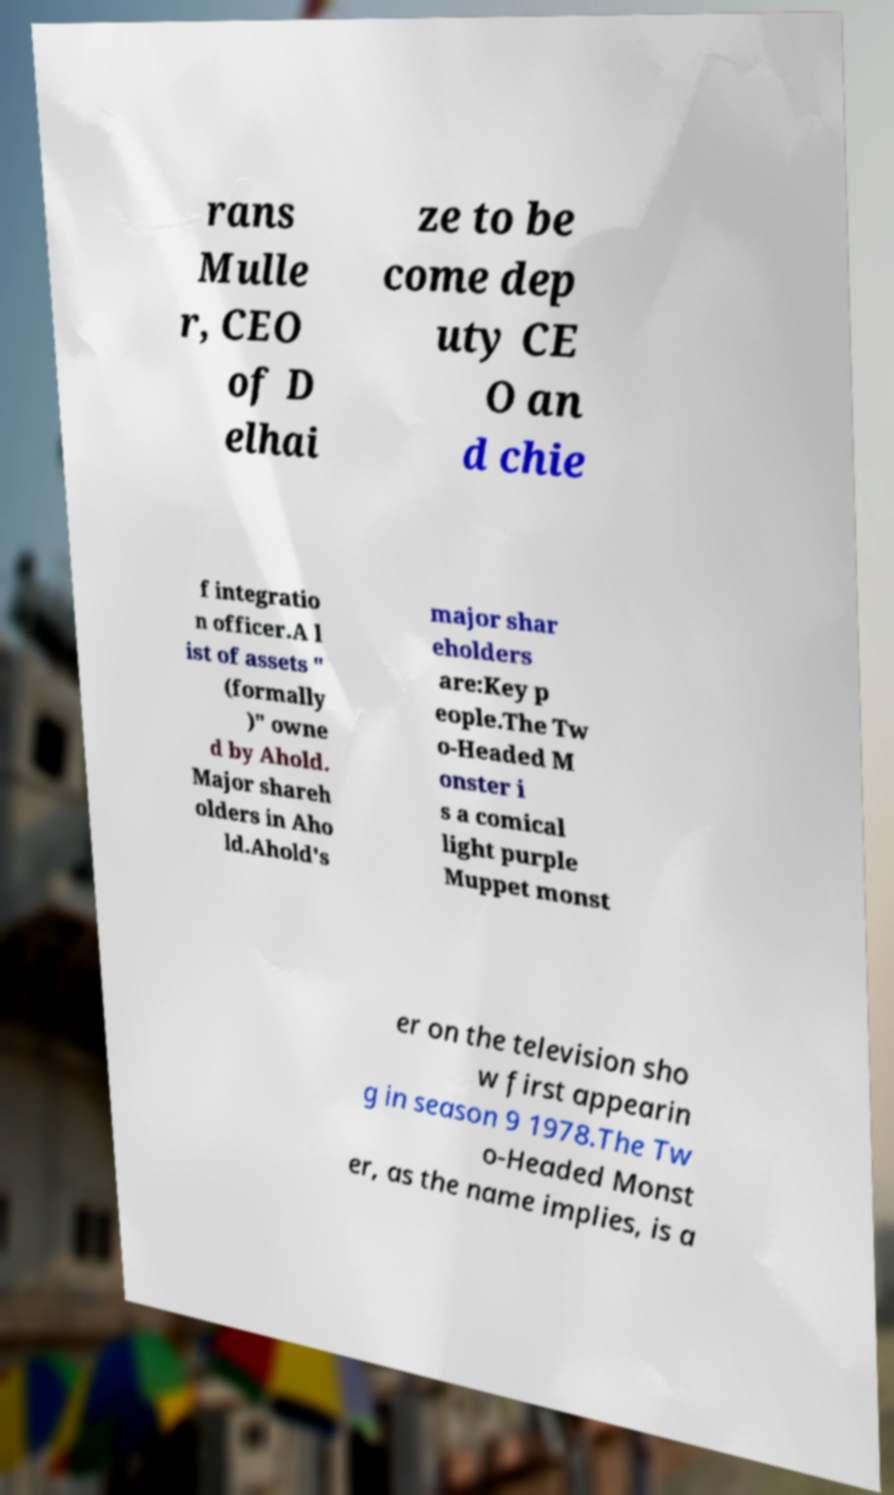What messages or text are displayed in this image? I need them in a readable, typed format. rans Mulle r, CEO of D elhai ze to be come dep uty CE O an d chie f integratio n officer.A l ist of assets " (formally )" owne d by Ahold. Major shareh olders in Aho ld.Ahold's major shar eholders are:Key p eople.The Tw o-Headed M onster i s a comical light purple Muppet monst er on the television sho w first appearin g in season 9 1978.The Tw o-Headed Monst er, as the name implies, is a 